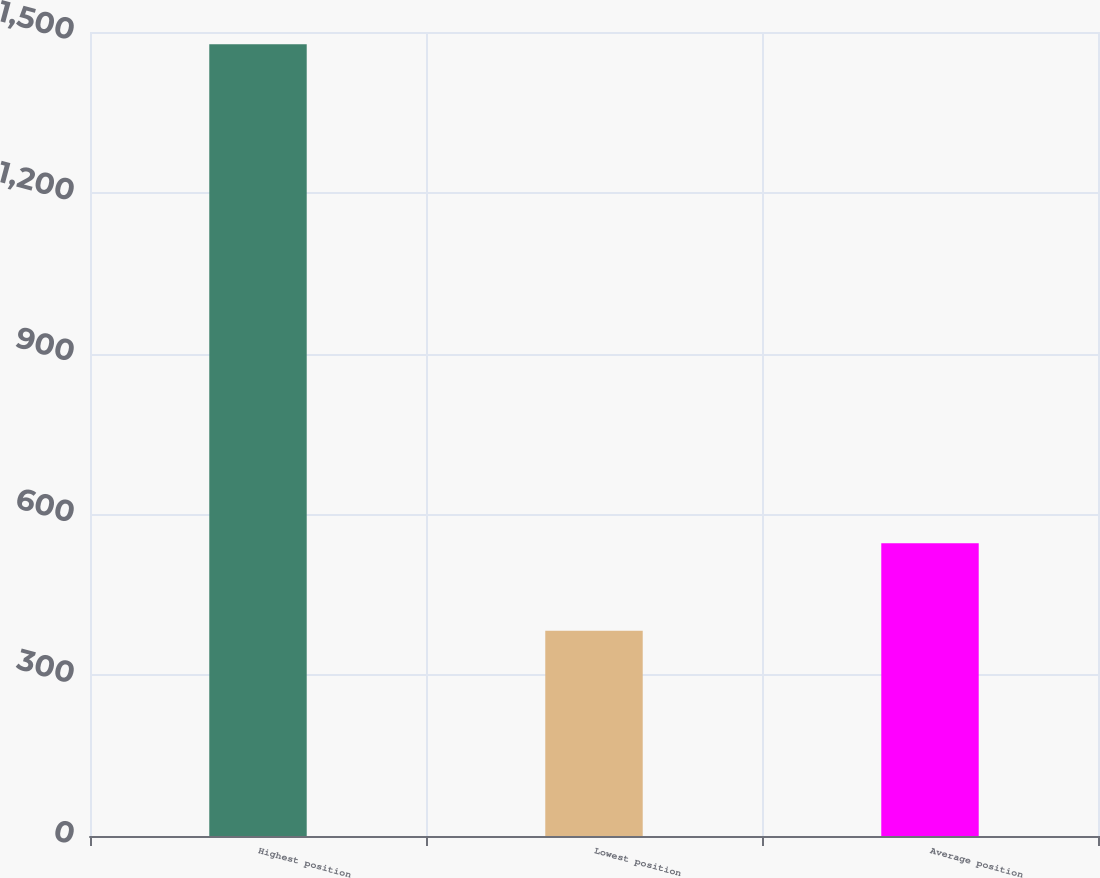Convert chart to OTSL. <chart><loc_0><loc_0><loc_500><loc_500><bar_chart><fcel>Highest position<fcel>Lowest position<fcel>Average position<nl><fcel>1477<fcel>383<fcel>546<nl></chart> 